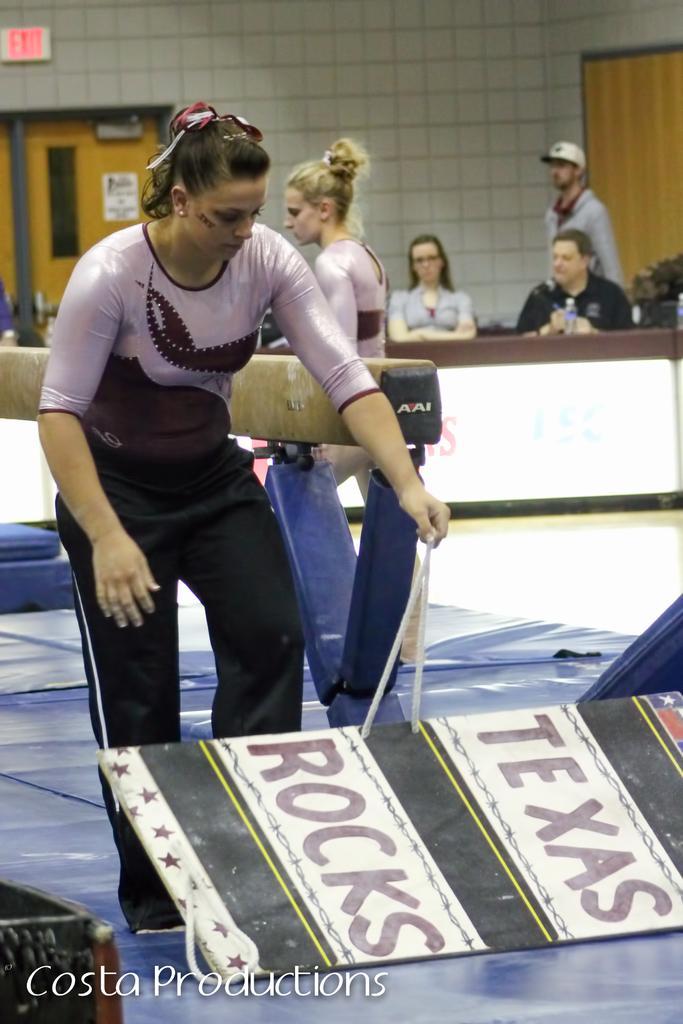In one or two sentences, can you explain what this image depicts? In this image I can see a lady standing and holding something, behind her there are some other people. 